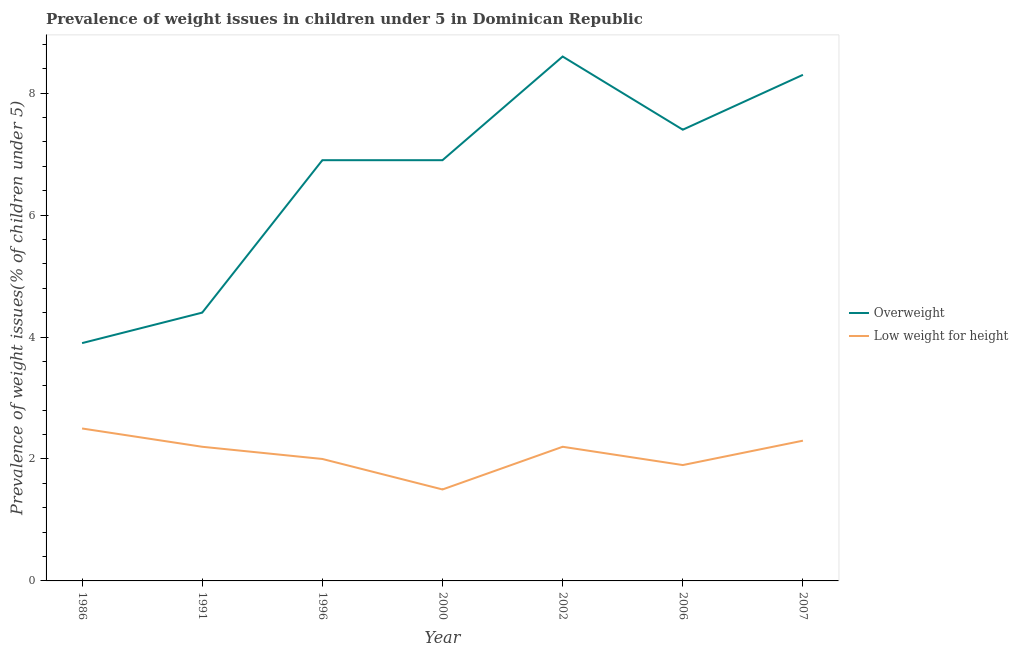Does the line corresponding to percentage of overweight children intersect with the line corresponding to percentage of underweight children?
Your answer should be very brief. No. What is the percentage of overweight children in 2002?
Your answer should be very brief. 8.6. Across all years, what is the maximum percentage of overweight children?
Provide a short and direct response. 8.6. In which year was the percentage of underweight children minimum?
Your response must be concise. 2000. What is the total percentage of underweight children in the graph?
Your answer should be very brief. 14.6. What is the difference between the percentage of underweight children in 1991 and that in 2006?
Make the answer very short. 0.3. What is the difference between the percentage of underweight children in 2006 and the percentage of overweight children in 2007?
Provide a short and direct response. -6.4. What is the average percentage of underweight children per year?
Ensure brevity in your answer.  2.09. In the year 2000, what is the difference between the percentage of underweight children and percentage of overweight children?
Provide a short and direct response. -5.4. What is the ratio of the percentage of overweight children in 1996 to that in 2002?
Provide a short and direct response. 0.8. What is the difference between the highest and the second highest percentage of underweight children?
Offer a terse response. 0.2. What is the difference between the highest and the lowest percentage of underweight children?
Your answer should be very brief. 1. In how many years, is the percentage of underweight children greater than the average percentage of underweight children taken over all years?
Provide a short and direct response. 4. Is the sum of the percentage of overweight children in 1986 and 1991 greater than the maximum percentage of underweight children across all years?
Your response must be concise. Yes. Does the percentage of underweight children monotonically increase over the years?
Keep it short and to the point. No. Is the percentage of overweight children strictly less than the percentage of underweight children over the years?
Ensure brevity in your answer.  No. How many years are there in the graph?
Your answer should be compact. 7. Are the values on the major ticks of Y-axis written in scientific E-notation?
Provide a short and direct response. No. Does the graph contain grids?
Offer a terse response. No. How are the legend labels stacked?
Provide a succinct answer. Vertical. What is the title of the graph?
Provide a succinct answer. Prevalence of weight issues in children under 5 in Dominican Republic. Does "Crop" appear as one of the legend labels in the graph?
Make the answer very short. No. What is the label or title of the X-axis?
Offer a terse response. Year. What is the label or title of the Y-axis?
Give a very brief answer. Prevalence of weight issues(% of children under 5). What is the Prevalence of weight issues(% of children under 5) of Overweight in 1986?
Provide a short and direct response. 3.9. What is the Prevalence of weight issues(% of children under 5) in Overweight in 1991?
Offer a very short reply. 4.4. What is the Prevalence of weight issues(% of children under 5) of Low weight for height in 1991?
Offer a very short reply. 2.2. What is the Prevalence of weight issues(% of children under 5) in Overweight in 1996?
Offer a terse response. 6.9. What is the Prevalence of weight issues(% of children under 5) of Low weight for height in 1996?
Keep it short and to the point. 2. What is the Prevalence of weight issues(% of children under 5) of Overweight in 2000?
Keep it short and to the point. 6.9. What is the Prevalence of weight issues(% of children under 5) of Low weight for height in 2000?
Keep it short and to the point. 1.5. What is the Prevalence of weight issues(% of children under 5) of Overweight in 2002?
Make the answer very short. 8.6. What is the Prevalence of weight issues(% of children under 5) of Low weight for height in 2002?
Give a very brief answer. 2.2. What is the Prevalence of weight issues(% of children under 5) of Overweight in 2006?
Your answer should be compact. 7.4. What is the Prevalence of weight issues(% of children under 5) of Low weight for height in 2006?
Give a very brief answer. 1.9. What is the Prevalence of weight issues(% of children under 5) of Overweight in 2007?
Make the answer very short. 8.3. What is the Prevalence of weight issues(% of children under 5) of Low weight for height in 2007?
Provide a succinct answer. 2.3. Across all years, what is the maximum Prevalence of weight issues(% of children under 5) of Overweight?
Keep it short and to the point. 8.6. Across all years, what is the minimum Prevalence of weight issues(% of children under 5) of Overweight?
Provide a short and direct response. 3.9. What is the total Prevalence of weight issues(% of children under 5) in Overweight in the graph?
Provide a succinct answer. 46.4. What is the difference between the Prevalence of weight issues(% of children under 5) of Low weight for height in 1986 and that in 1991?
Provide a succinct answer. 0.3. What is the difference between the Prevalence of weight issues(% of children under 5) of Overweight in 1986 and that in 1996?
Make the answer very short. -3. What is the difference between the Prevalence of weight issues(% of children under 5) in Low weight for height in 1986 and that in 1996?
Provide a short and direct response. 0.5. What is the difference between the Prevalence of weight issues(% of children under 5) in Overweight in 1986 and that in 2000?
Give a very brief answer. -3. What is the difference between the Prevalence of weight issues(% of children under 5) of Low weight for height in 1986 and that in 2000?
Your response must be concise. 1. What is the difference between the Prevalence of weight issues(% of children under 5) in Overweight in 1986 and that in 2002?
Ensure brevity in your answer.  -4.7. What is the difference between the Prevalence of weight issues(% of children under 5) of Low weight for height in 1986 and that in 2002?
Your response must be concise. 0.3. What is the difference between the Prevalence of weight issues(% of children under 5) of Overweight in 1986 and that in 2007?
Make the answer very short. -4.4. What is the difference between the Prevalence of weight issues(% of children under 5) of Low weight for height in 1986 and that in 2007?
Offer a very short reply. 0.2. What is the difference between the Prevalence of weight issues(% of children under 5) in Overweight in 1991 and that in 1996?
Provide a succinct answer. -2.5. What is the difference between the Prevalence of weight issues(% of children under 5) in Low weight for height in 1991 and that in 1996?
Offer a very short reply. 0.2. What is the difference between the Prevalence of weight issues(% of children under 5) of Overweight in 1991 and that in 2000?
Offer a very short reply. -2.5. What is the difference between the Prevalence of weight issues(% of children under 5) of Low weight for height in 1991 and that in 2000?
Provide a succinct answer. 0.7. What is the difference between the Prevalence of weight issues(% of children under 5) of Overweight in 1991 and that in 2002?
Your answer should be very brief. -4.2. What is the difference between the Prevalence of weight issues(% of children under 5) of Low weight for height in 1991 and that in 2002?
Provide a succinct answer. 0. What is the difference between the Prevalence of weight issues(% of children under 5) in Low weight for height in 1991 and that in 2006?
Your answer should be compact. 0.3. What is the difference between the Prevalence of weight issues(% of children under 5) of Overweight in 1996 and that in 2000?
Your answer should be very brief. 0. What is the difference between the Prevalence of weight issues(% of children under 5) in Low weight for height in 1996 and that in 2000?
Ensure brevity in your answer.  0.5. What is the difference between the Prevalence of weight issues(% of children under 5) in Low weight for height in 1996 and that in 2002?
Offer a terse response. -0.2. What is the difference between the Prevalence of weight issues(% of children under 5) of Overweight in 1996 and that in 2007?
Make the answer very short. -1.4. What is the difference between the Prevalence of weight issues(% of children under 5) of Overweight in 2000 and that in 2002?
Provide a short and direct response. -1.7. What is the difference between the Prevalence of weight issues(% of children under 5) in Low weight for height in 2000 and that in 2002?
Your answer should be compact. -0.7. What is the difference between the Prevalence of weight issues(% of children under 5) of Overweight in 2000 and that in 2006?
Offer a very short reply. -0.5. What is the difference between the Prevalence of weight issues(% of children under 5) of Overweight in 2000 and that in 2007?
Provide a succinct answer. -1.4. What is the difference between the Prevalence of weight issues(% of children under 5) in Low weight for height in 2000 and that in 2007?
Offer a very short reply. -0.8. What is the difference between the Prevalence of weight issues(% of children under 5) in Overweight in 2002 and that in 2006?
Offer a very short reply. 1.2. What is the difference between the Prevalence of weight issues(% of children under 5) in Low weight for height in 2002 and that in 2006?
Keep it short and to the point. 0.3. What is the difference between the Prevalence of weight issues(% of children under 5) of Low weight for height in 2002 and that in 2007?
Give a very brief answer. -0.1. What is the difference between the Prevalence of weight issues(% of children under 5) in Low weight for height in 2006 and that in 2007?
Give a very brief answer. -0.4. What is the difference between the Prevalence of weight issues(% of children under 5) in Overweight in 1986 and the Prevalence of weight issues(% of children under 5) in Low weight for height in 1991?
Your answer should be compact. 1.7. What is the difference between the Prevalence of weight issues(% of children under 5) in Overweight in 1986 and the Prevalence of weight issues(% of children under 5) in Low weight for height in 2002?
Your response must be concise. 1.7. What is the difference between the Prevalence of weight issues(% of children under 5) in Overweight in 1986 and the Prevalence of weight issues(% of children under 5) in Low weight for height in 2006?
Your response must be concise. 2. What is the difference between the Prevalence of weight issues(% of children under 5) of Overweight in 1991 and the Prevalence of weight issues(% of children under 5) of Low weight for height in 2002?
Keep it short and to the point. 2.2. What is the difference between the Prevalence of weight issues(% of children under 5) in Overweight in 1996 and the Prevalence of weight issues(% of children under 5) in Low weight for height in 2000?
Your answer should be compact. 5.4. What is the difference between the Prevalence of weight issues(% of children under 5) of Overweight in 1996 and the Prevalence of weight issues(% of children under 5) of Low weight for height in 2006?
Keep it short and to the point. 5. What is the difference between the Prevalence of weight issues(% of children under 5) in Overweight in 2000 and the Prevalence of weight issues(% of children under 5) in Low weight for height in 2002?
Make the answer very short. 4.7. What is the difference between the Prevalence of weight issues(% of children under 5) in Overweight in 2000 and the Prevalence of weight issues(% of children under 5) in Low weight for height in 2006?
Give a very brief answer. 5. What is the difference between the Prevalence of weight issues(% of children under 5) in Overweight in 2000 and the Prevalence of weight issues(% of children under 5) in Low weight for height in 2007?
Your response must be concise. 4.6. What is the difference between the Prevalence of weight issues(% of children under 5) of Overweight in 2002 and the Prevalence of weight issues(% of children under 5) of Low weight for height in 2006?
Provide a short and direct response. 6.7. What is the difference between the Prevalence of weight issues(% of children under 5) in Overweight in 2002 and the Prevalence of weight issues(% of children under 5) in Low weight for height in 2007?
Your answer should be compact. 6.3. What is the difference between the Prevalence of weight issues(% of children under 5) of Overweight in 2006 and the Prevalence of weight issues(% of children under 5) of Low weight for height in 2007?
Make the answer very short. 5.1. What is the average Prevalence of weight issues(% of children under 5) of Overweight per year?
Your answer should be compact. 6.63. What is the average Prevalence of weight issues(% of children under 5) in Low weight for height per year?
Ensure brevity in your answer.  2.09. In the year 1986, what is the difference between the Prevalence of weight issues(% of children under 5) in Overweight and Prevalence of weight issues(% of children under 5) in Low weight for height?
Provide a succinct answer. 1.4. In the year 1996, what is the difference between the Prevalence of weight issues(% of children under 5) of Overweight and Prevalence of weight issues(% of children under 5) of Low weight for height?
Provide a succinct answer. 4.9. In the year 2000, what is the difference between the Prevalence of weight issues(% of children under 5) in Overweight and Prevalence of weight issues(% of children under 5) in Low weight for height?
Provide a short and direct response. 5.4. In the year 2006, what is the difference between the Prevalence of weight issues(% of children under 5) of Overweight and Prevalence of weight issues(% of children under 5) of Low weight for height?
Provide a succinct answer. 5.5. In the year 2007, what is the difference between the Prevalence of weight issues(% of children under 5) of Overweight and Prevalence of weight issues(% of children under 5) of Low weight for height?
Provide a succinct answer. 6. What is the ratio of the Prevalence of weight issues(% of children under 5) of Overweight in 1986 to that in 1991?
Your answer should be compact. 0.89. What is the ratio of the Prevalence of weight issues(% of children under 5) in Low weight for height in 1986 to that in 1991?
Your answer should be very brief. 1.14. What is the ratio of the Prevalence of weight issues(% of children under 5) of Overweight in 1986 to that in 1996?
Offer a terse response. 0.57. What is the ratio of the Prevalence of weight issues(% of children under 5) of Overweight in 1986 to that in 2000?
Give a very brief answer. 0.57. What is the ratio of the Prevalence of weight issues(% of children under 5) of Overweight in 1986 to that in 2002?
Your answer should be compact. 0.45. What is the ratio of the Prevalence of weight issues(% of children under 5) in Low weight for height in 1986 to that in 2002?
Keep it short and to the point. 1.14. What is the ratio of the Prevalence of weight issues(% of children under 5) of Overweight in 1986 to that in 2006?
Ensure brevity in your answer.  0.53. What is the ratio of the Prevalence of weight issues(% of children under 5) of Low weight for height in 1986 to that in 2006?
Provide a short and direct response. 1.32. What is the ratio of the Prevalence of weight issues(% of children under 5) in Overweight in 1986 to that in 2007?
Offer a very short reply. 0.47. What is the ratio of the Prevalence of weight issues(% of children under 5) of Low weight for height in 1986 to that in 2007?
Your answer should be compact. 1.09. What is the ratio of the Prevalence of weight issues(% of children under 5) of Overweight in 1991 to that in 1996?
Make the answer very short. 0.64. What is the ratio of the Prevalence of weight issues(% of children under 5) of Overweight in 1991 to that in 2000?
Offer a terse response. 0.64. What is the ratio of the Prevalence of weight issues(% of children under 5) of Low weight for height in 1991 to that in 2000?
Provide a succinct answer. 1.47. What is the ratio of the Prevalence of weight issues(% of children under 5) in Overweight in 1991 to that in 2002?
Provide a succinct answer. 0.51. What is the ratio of the Prevalence of weight issues(% of children under 5) in Low weight for height in 1991 to that in 2002?
Make the answer very short. 1. What is the ratio of the Prevalence of weight issues(% of children under 5) of Overweight in 1991 to that in 2006?
Keep it short and to the point. 0.59. What is the ratio of the Prevalence of weight issues(% of children under 5) in Low weight for height in 1991 to that in 2006?
Offer a very short reply. 1.16. What is the ratio of the Prevalence of weight issues(% of children under 5) of Overweight in 1991 to that in 2007?
Provide a short and direct response. 0.53. What is the ratio of the Prevalence of weight issues(% of children under 5) in Low weight for height in 1991 to that in 2007?
Provide a short and direct response. 0.96. What is the ratio of the Prevalence of weight issues(% of children under 5) of Overweight in 1996 to that in 2002?
Provide a succinct answer. 0.8. What is the ratio of the Prevalence of weight issues(% of children under 5) of Overweight in 1996 to that in 2006?
Your answer should be very brief. 0.93. What is the ratio of the Prevalence of weight issues(% of children under 5) of Low weight for height in 1996 to that in 2006?
Keep it short and to the point. 1.05. What is the ratio of the Prevalence of weight issues(% of children under 5) of Overweight in 1996 to that in 2007?
Offer a very short reply. 0.83. What is the ratio of the Prevalence of weight issues(% of children under 5) in Low weight for height in 1996 to that in 2007?
Provide a succinct answer. 0.87. What is the ratio of the Prevalence of weight issues(% of children under 5) of Overweight in 2000 to that in 2002?
Your answer should be compact. 0.8. What is the ratio of the Prevalence of weight issues(% of children under 5) in Low weight for height in 2000 to that in 2002?
Ensure brevity in your answer.  0.68. What is the ratio of the Prevalence of weight issues(% of children under 5) in Overweight in 2000 to that in 2006?
Keep it short and to the point. 0.93. What is the ratio of the Prevalence of weight issues(% of children under 5) of Low weight for height in 2000 to that in 2006?
Your answer should be compact. 0.79. What is the ratio of the Prevalence of weight issues(% of children under 5) in Overweight in 2000 to that in 2007?
Provide a succinct answer. 0.83. What is the ratio of the Prevalence of weight issues(% of children under 5) in Low weight for height in 2000 to that in 2007?
Your answer should be compact. 0.65. What is the ratio of the Prevalence of weight issues(% of children under 5) of Overweight in 2002 to that in 2006?
Offer a very short reply. 1.16. What is the ratio of the Prevalence of weight issues(% of children under 5) of Low weight for height in 2002 to that in 2006?
Give a very brief answer. 1.16. What is the ratio of the Prevalence of weight issues(% of children under 5) in Overweight in 2002 to that in 2007?
Your answer should be very brief. 1.04. What is the ratio of the Prevalence of weight issues(% of children under 5) of Low weight for height in 2002 to that in 2007?
Give a very brief answer. 0.96. What is the ratio of the Prevalence of weight issues(% of children under 5) of Overweight in 2006 to that in 2007?
Keep it short and to the point. 0.89. What is the ratio of the Prevalence of weight issues(% of children under 5) of Low weight for height in 2006 to that in 2007?
Make the answer very short. 0.83. What is the difference between the highest and the second highest Prevalence of weight issues(% of children under 5) of Low weight for height?
Make the answer very short. 0.2. 